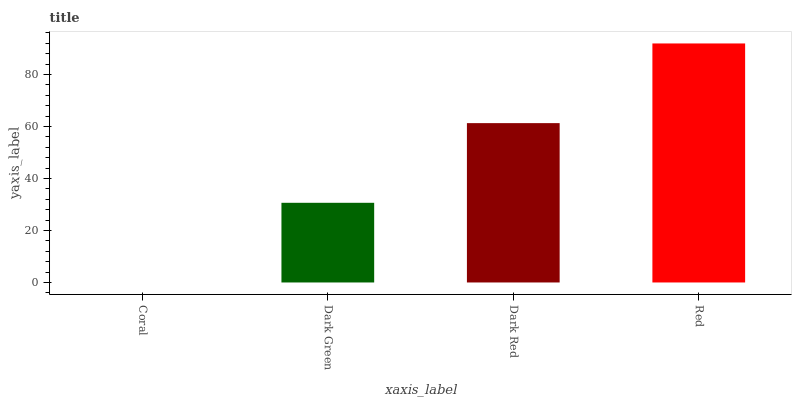Is Coral the minimum?
Answer yes or no. Yes. Is Red the maximum?
Answer yes or no. Yes. Is Dark Green the minimum?
Answer yes or no. No. Is Dark Green the maximum?
Answer yes or no. No. Is Dark Green greater than Coral?
Answer yes or no. Yes. Is Coral less than Dark Green?
Answer yes or no. Yes. Is Coral greater than Dark Green?
Answer yes or no. No. Is Dark Green less than Coral?
Answer yes or no. No. Is Dark Red the high median?
Answer yes or no. Yes. Is Dark Green the low median?
Answer yes or no. Yes. Is Dark Green the high median?
Answer yes or no. No. Is Coral the low median?
Answer yes or no. No. 